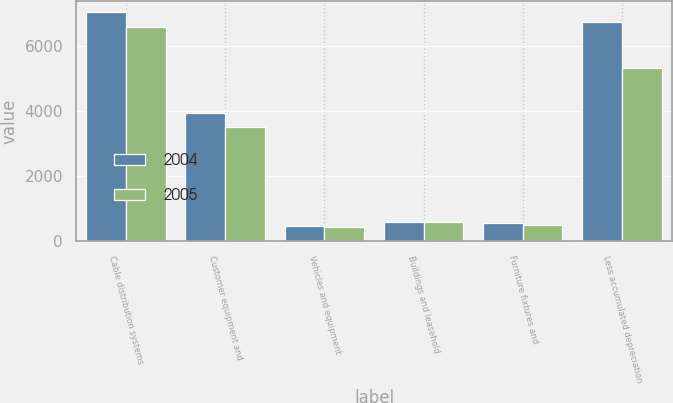Convert chart to OTSL. <chart><loc_0><loc_0><loc_500><loc_500><stacked_bar_chart><ecel><fcel>Cable distribution systems<fcel>Customer equipment and<fcel>Vehicles and equipment<fcel>Buildings and leasehold<fcel>Furniture fixtures and<fcel>Less accumulated depreciation<nl><fcel>2004<fcel>7035<fcel>3934<fcel>473<fcel>584<fcel>563<fcel>6749<nl><fcel>2005<fcel>6596<fcel>3500<fcel>433<fcel>578<fcel>493<fcel>5311<nl></chart> 